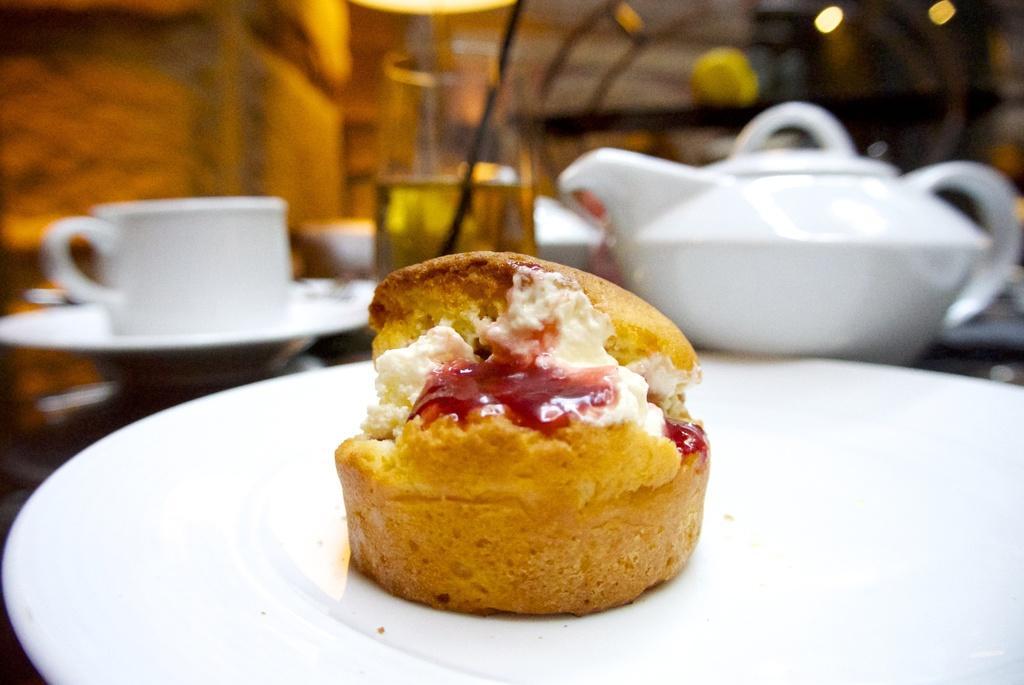Please provide a concise description of this image. In this image I can see the food in the plate and the food is in brown, red and white color and the plate is in white color. In the background I can see few glasses and I can also see the tea pot. 